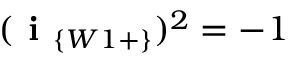Convert formula to latex. <formula><loc_0><loc_0><loc_500><loc_500>( i _ { \{ W 1 + \} } ) ^ { 2 } = - 1</formula> 